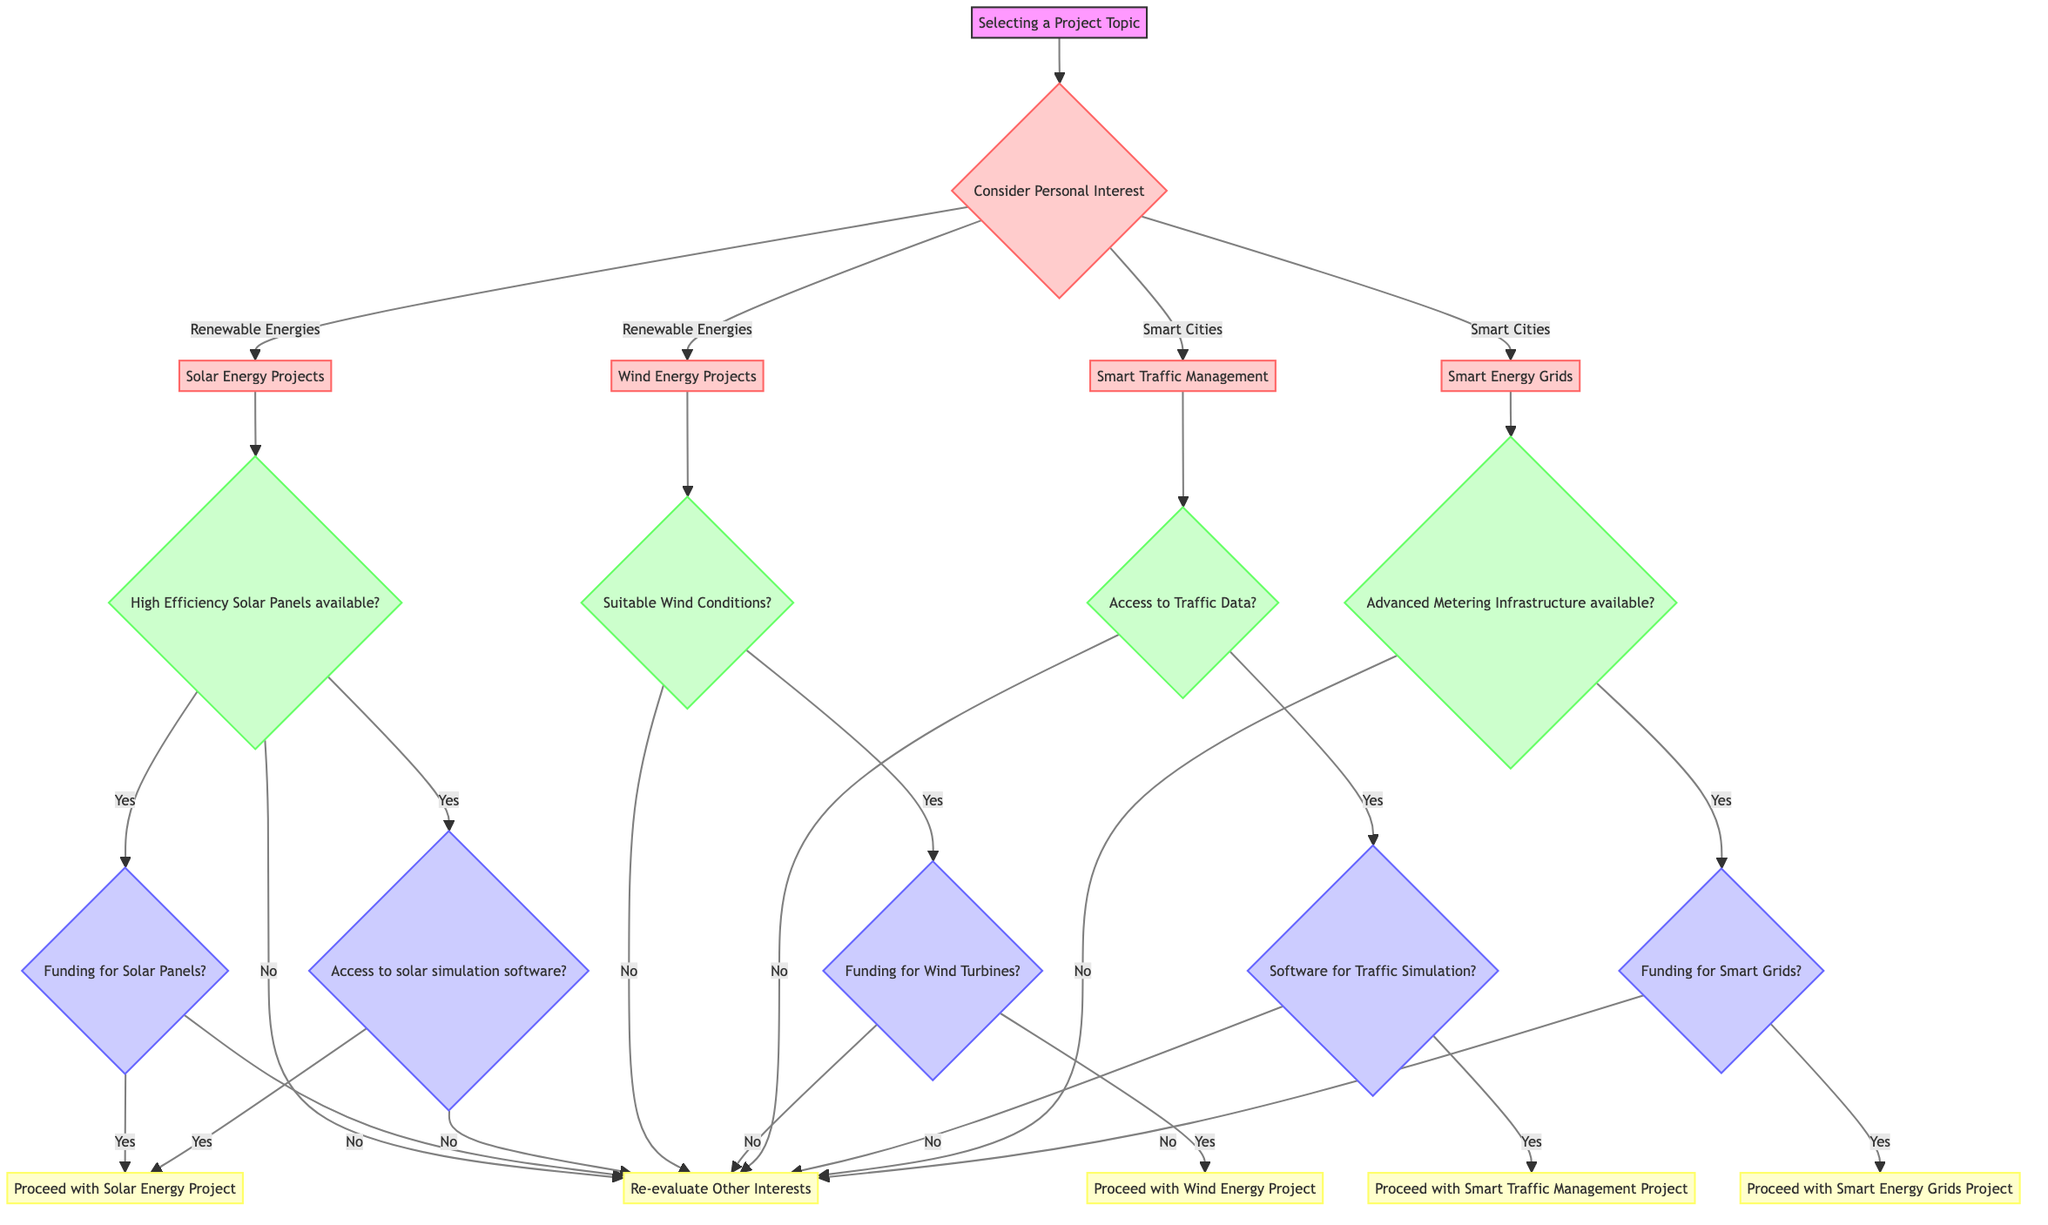What are the two main categories of project topics considered in the decision tree? The decision tree starts with two main categories: Renewable Energies and Smart Cities. Each of these categories has sub-options that further detail possible project topics.
Answer: Renewable Energies and Smart Cities Which renewable energy project considers wind conditions? The wind energy projects are evaluated based on whether suitable wind conditions are present. The decision tree indicates this as a specific condition for proceeding with wind energy projects.
Answer: Wind Energy Projects What happens if high efficiency solar panels are not available? If high efficiency solar panels are not available, the decision tree indicates that the next step is to re-evaluate other interests, indicating that this project option can't proceed without this key resource.
Answer: Re-evaluate Other Interests How many options are available under Smart Cities? The Smart Cities category includes two options: Smart Traffic Management and Smart Energy Grids, according to what is outlined in the decision tree structure.
Answer: Two options What condition needs to be met for proceeding with the Smart Traffic Management project? Access to traffic data is essential for evaluating the technical feasibility of the Smart Traffic Management project, which is followed by checking for the availability of software for traffic simulation.
Answer: Access to Traffic Data If funding for solar panels is not available, what should be done? If funding for solar panels is not available, the decision tree directs the user to re-evaluate other interests, indicating there's insufficient resource support to continue with the solar energy project.
Answer: Re-evaluate Other Interests What is the next step after confirming advanced metering infrastructure is available for Smart Energy Grids? Once advanced metering infrastructure is confirmed, the next step is to check for funding for smart grids, which is essential to proceed with the Smart Energy Grids project.
Answer: Check Funding for Smart Grids What decision is made if suitable wind conditions are identified but funding for wind turbines is lacking? If suitable wind conditions are identified but there is no funding for wind turbines, the decision tree indicates to re-evaluate other interests, meaning this project is also not viable under these conditions.
Answer: Re-evaluate Other Interests What is the final implied decision if all conditions and resources are favorable for either solar or wind energy projects? If all conditions and resources (high efficiency solar panels or suitable wind conditions, along with funding) are favorable, the decision is to proceed with either the Solar Energy Project or Wind Energy Project, respectively.
Answer: Proceed with the Project 